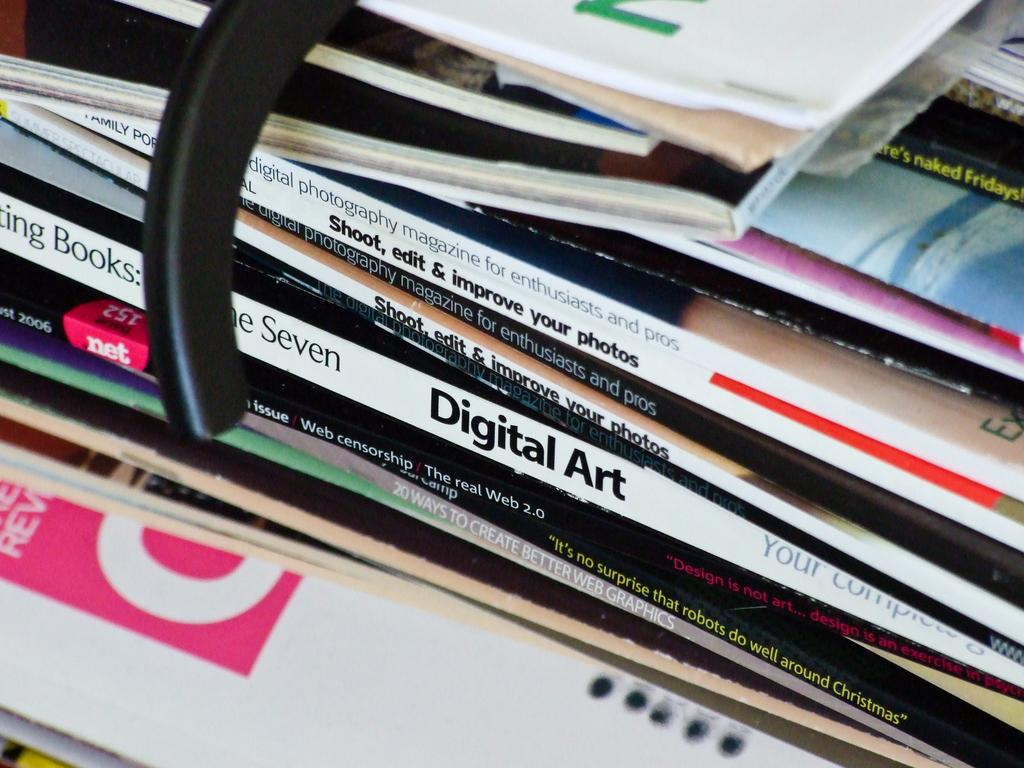Provide a one-sentence caption for the provided image. A stack of magazine has an issue of "Digital Art" in the middle of the pile. 